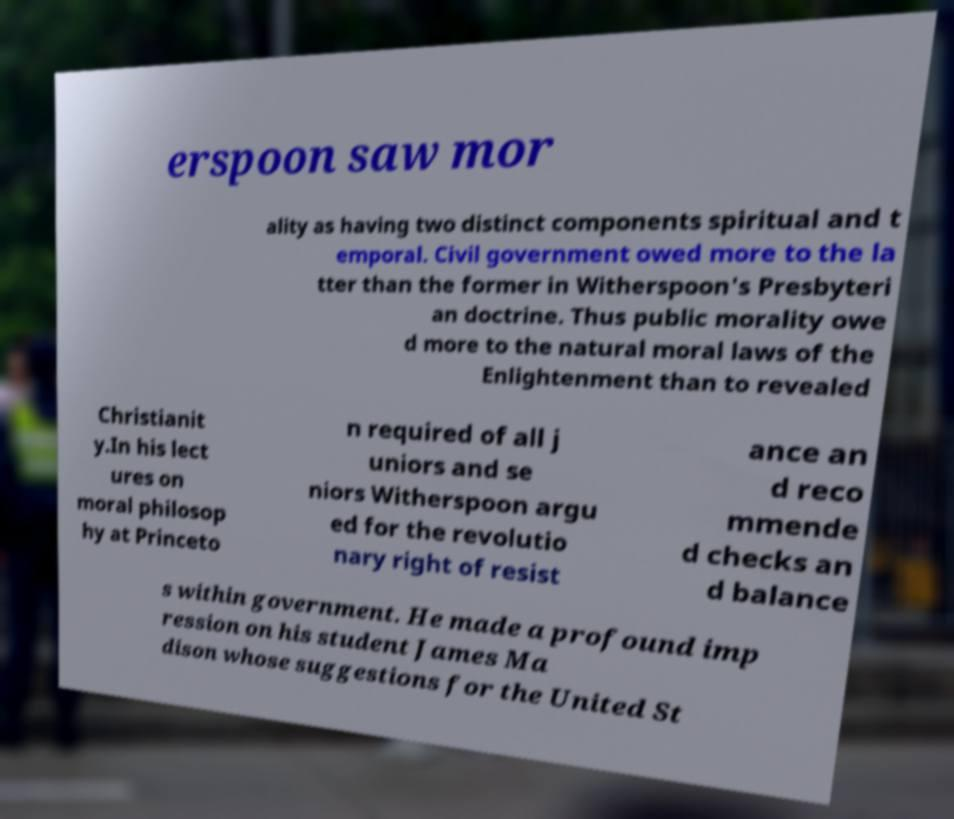Can you read and provide the text displayed in the image?This photo seems to have some interesting text. Can you extract and type it out for me? erspoon saw mor ality as having two distinct components spiritual and t emporal. Civil government owed more to the la tter than the former in Witherspoon's Presbyteri an doctrine. Thus public morality owe d more to the natural moral laws of the Enlightenment than to revealed Christianit y.In his lect ures on moral philosop hy at Princeto n required of all j uniors and se niors Witherspoon argu ed for the revolutio nary right of resist ance an d reco mmende d checks an d balance s within government. He made a profound imp ression on his student James Ma dison whose suggestions for the United St 